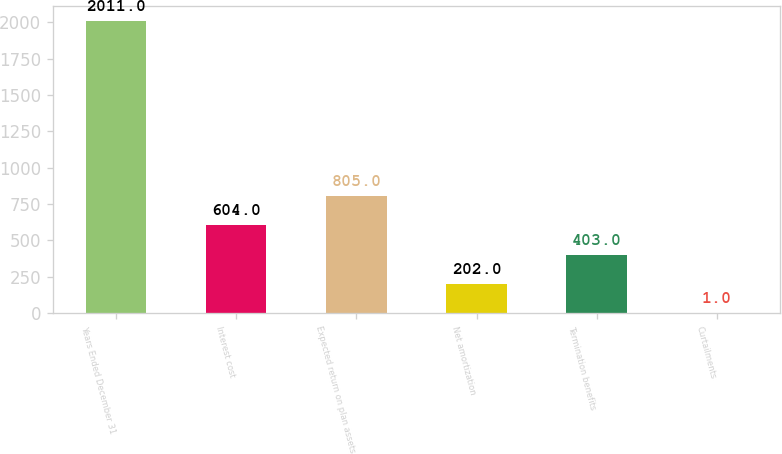Convert chart to OTSL. <chart><loc_0><loc_0><loc_500><loc_500><bar_chart><fcel>Years Ended December 31<fcel>Interest cost<fcel>Expected return on plan assets<fcel>Net amortization<fcel>Termination benefits<fcel>Curtailments<nl><fcel>2011<fcel>604<fcel>805<fcel>202<fcel>403<fcel>1<nl></chart> 